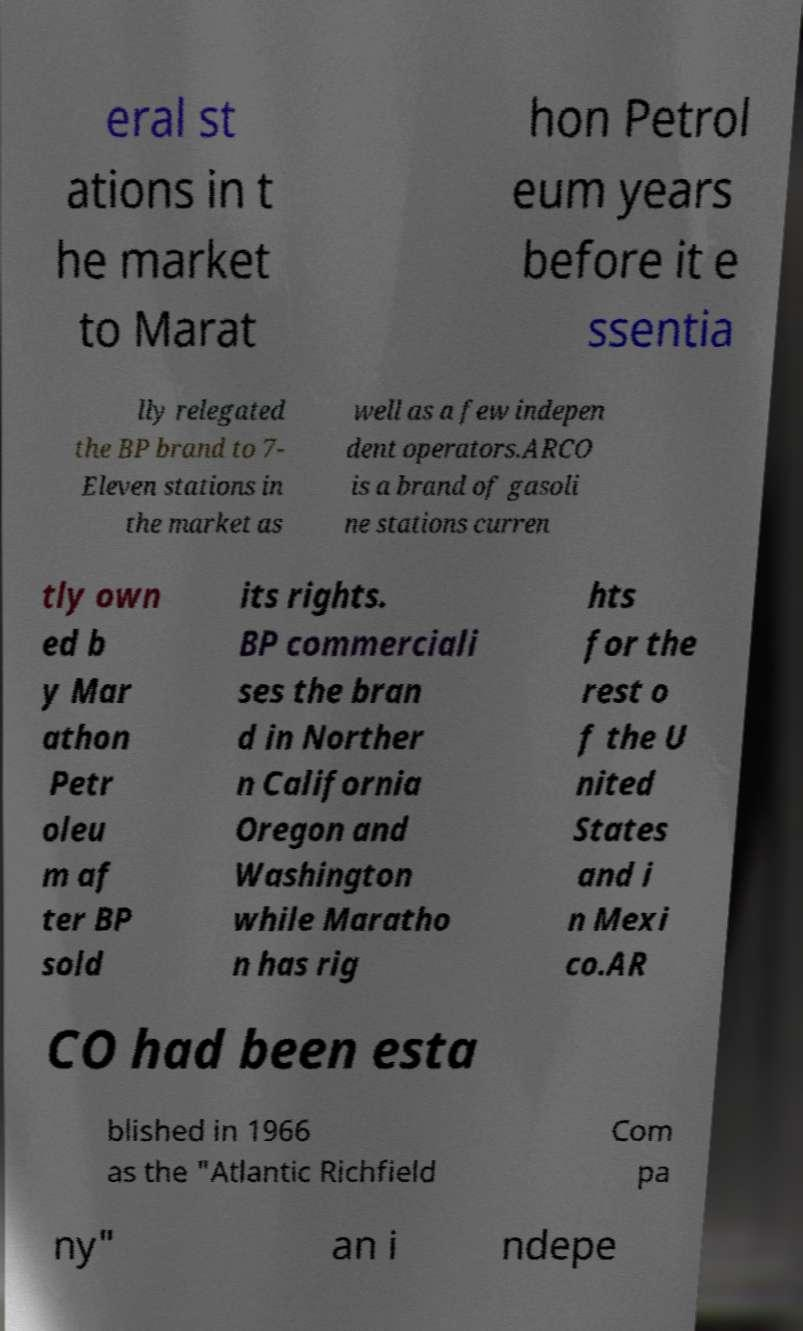For documentation purposes, I need the text within this image transcribed. Could you provide that? eral st ations in t he market to Marat hon Petrol eum years before it e ssentia lly relegated the BP brand to 7- Eleven stations in the market as well as a few indepen dent operators.ARCO is a brand of gasoli ne stations curren tly own ed b y Mar athon Petr oleu m af ter BP sold its rights. BP commerciali ses the bran d in Norther n California Oregon and Washington while Maratho n has rig hts for the rest o f the U nited States and i n Mexi co.AR CO had been esta blished in 1966 as the "Atlantic Richfield Com pa ny" an i ndepe 